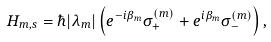Convert formula to latex. <formula><loc_0><loc_0><loc_500><loc_500>H _ { m , s } = \hbar { | } \lambda _ { m } | \left ( e ^ { - i \beta _ { m } } \sigma ^ { ( m ) } _ { + } + e ^ { i \beta _ { m } } \sigma ^ { ( m ) } _ { - } \right ) ,</formula> 